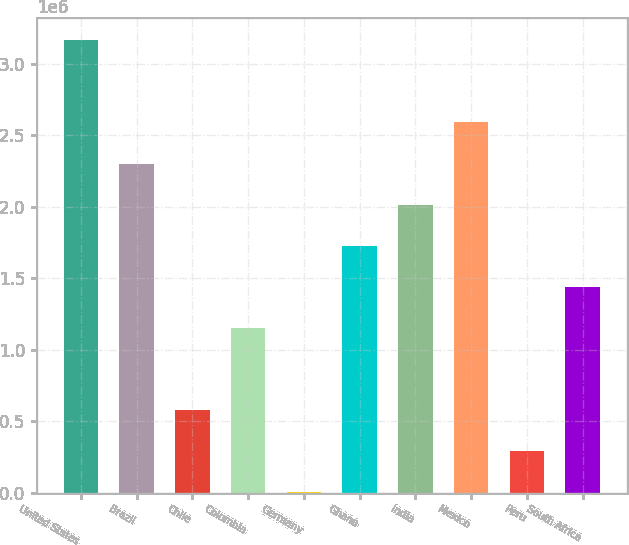Convert chart to OTSL. <chart><loc_0><loc_0><loc_500><loc_500><bar_chart><fcel>United States<fcel>Brazil<fcel>Chile<fcel>Colombia<fcel>Germany<fcel>Ghana<fcel>India<fcel>Mexico<fcel>Peru<fcel>South Africa<nl><fcel>3.16315e+06<fcel>2.30157e+06<fcel>578416<fcel>1.1528e+06<fcel>4030<fcel>1.72719e+06<fcel>2.01438e+06<fcel>2.58877e+06<fcel>291223<fcel>1.44e+06<nl></chart> 